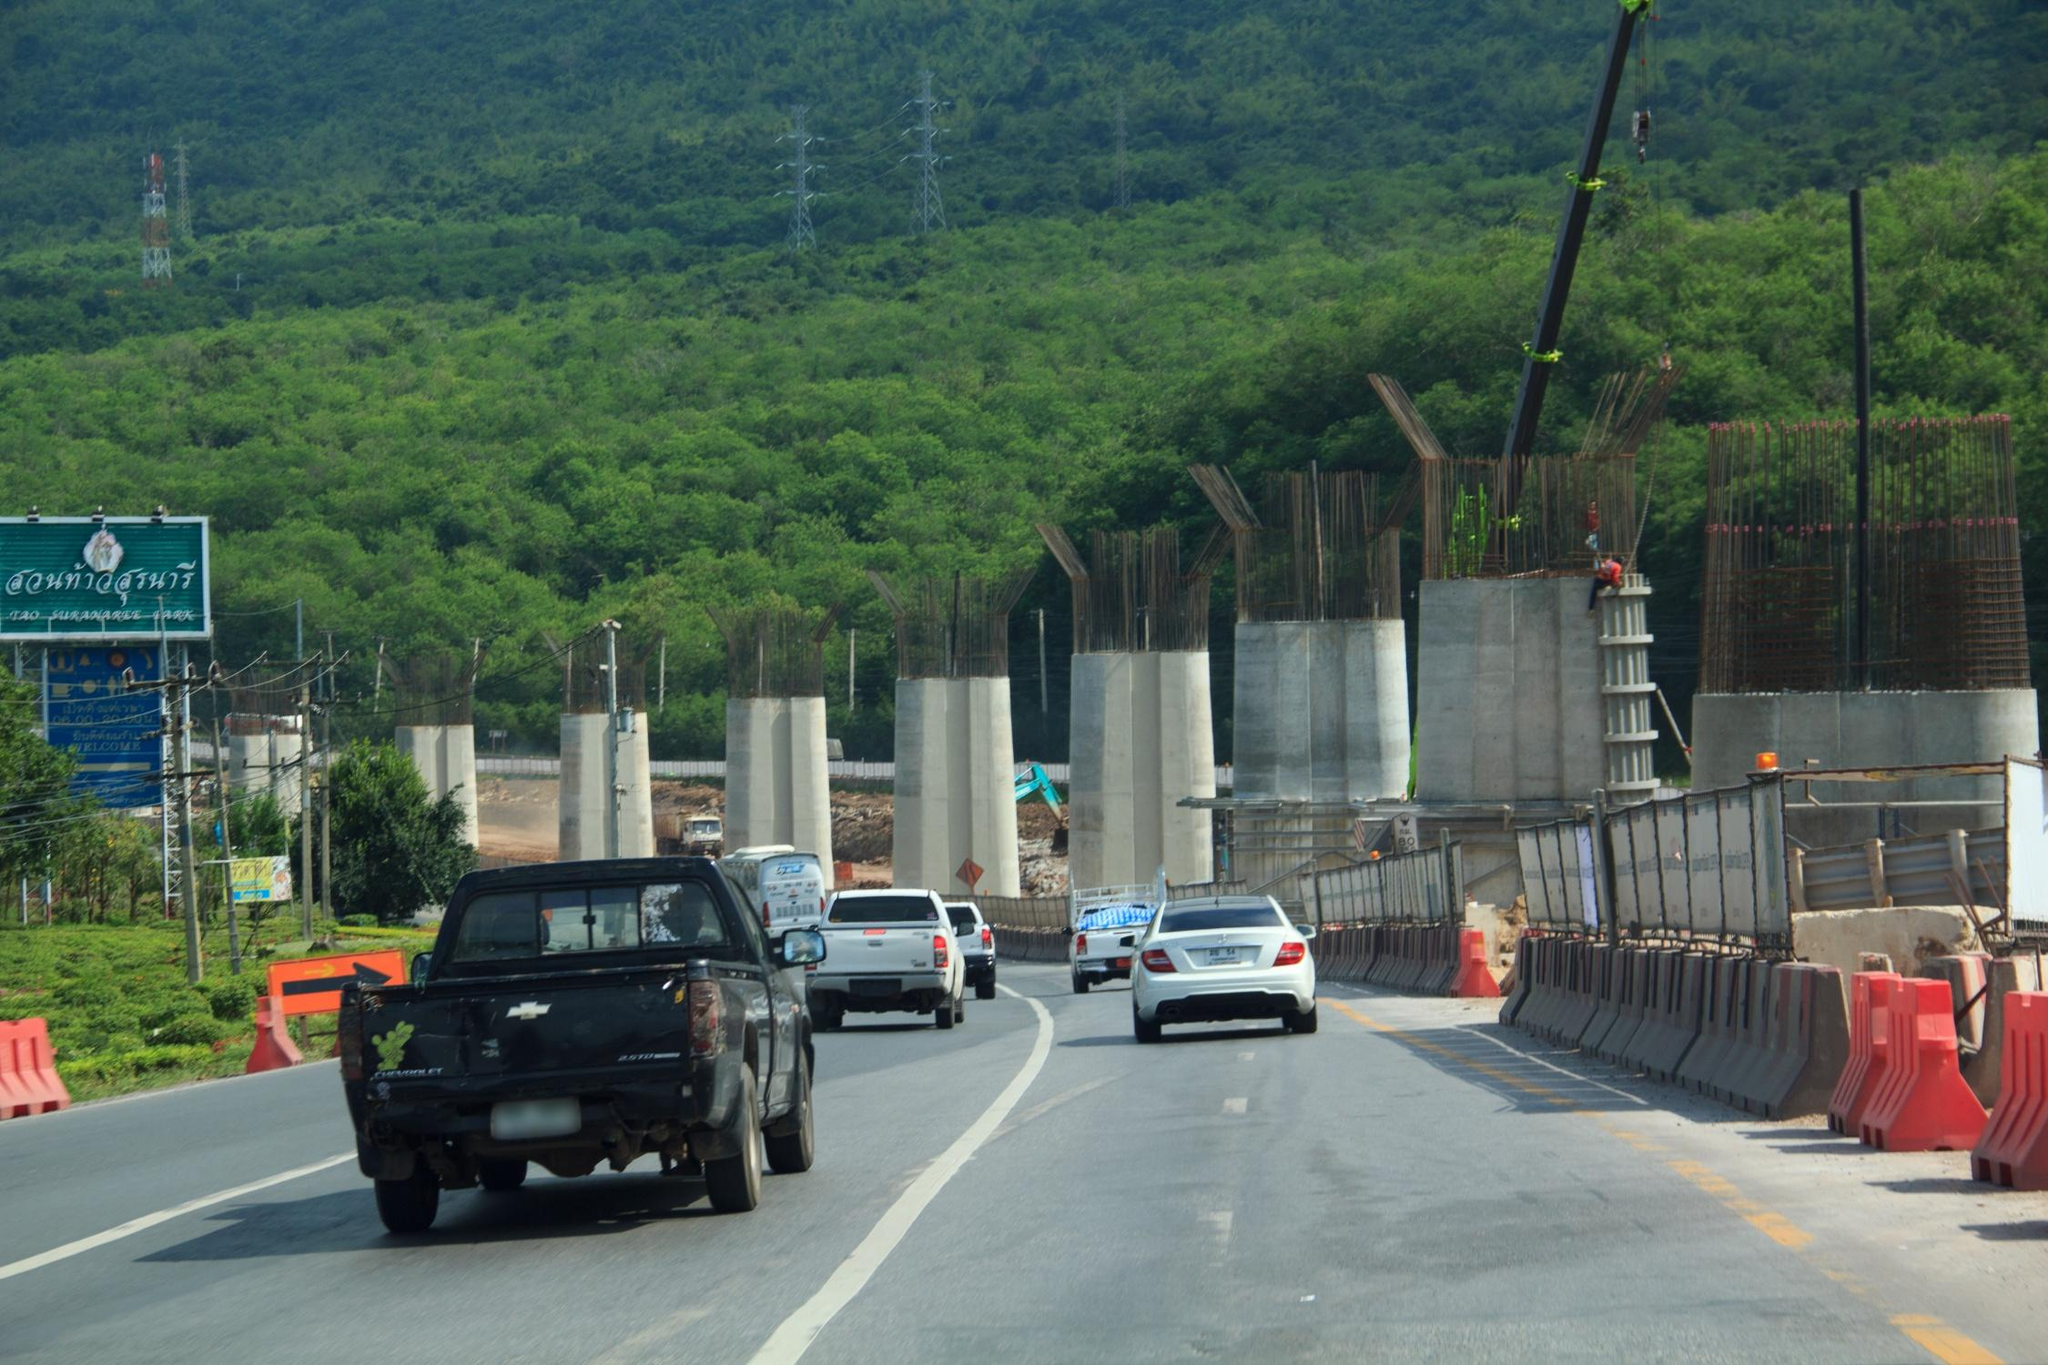Can you elaborate on the construction and its potential impact on the surrounding environment? Certainly! The construction depicted in the image appears to be a large-scale highway project, potentially aimed at improving transportation connectivity and efficiency in the region. Such developments typically have a significant impact on the surrounding environment, both positive and negative. On the positive side, upon completion, the new highway could enhance economic growth, reduce travel time, and improve access to remote areas. However, on the negative side, the construction process might disrupt local wildlife habitats, contribute to deforestation, and cause temporary air and noise pollution. Mitigating these effects involves careful planning, environmental assessments, and implementation of sustainable practices, such as creating wildlife corridors and using eco-friendly construction materials. 